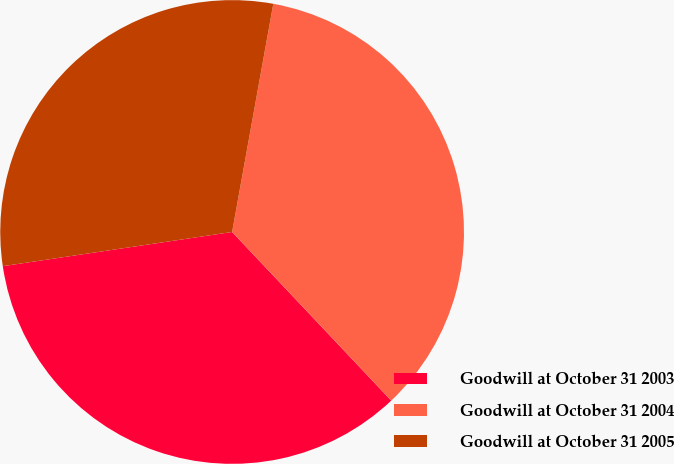<chart> <loc_0><loc_0><loc_500><loc_500><pie_chart><fcel>Goodwill at October 31 2003<fcel>Goodwill at October 31 2004<fcel>Goodwill at October 31 2005<nl><fcel>34.68%<fcel>35.12%<fcel>30.2%<nl></chart> 